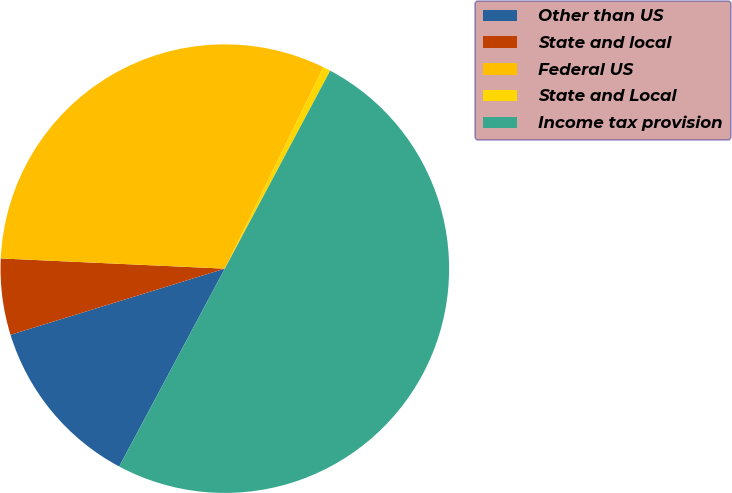Convert chart to OTSL. <chart><loc_0><loc_0><loc_500><loc_500><pie_chart><fcel>Other than US<fcel>State and local<fcel>Federal US<fcel>State and Local<fcel>Income tax provision<nl><fcel>12.43%<fcel>5.49%<fcel>31.52%<fcel>0.54%<fcel>50.02%<nl></chart> 